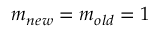<formula> <loc_0><loc_0><loc_500><loc_500>m _ { n e w } = m _ { o l d } = 1</formula> 